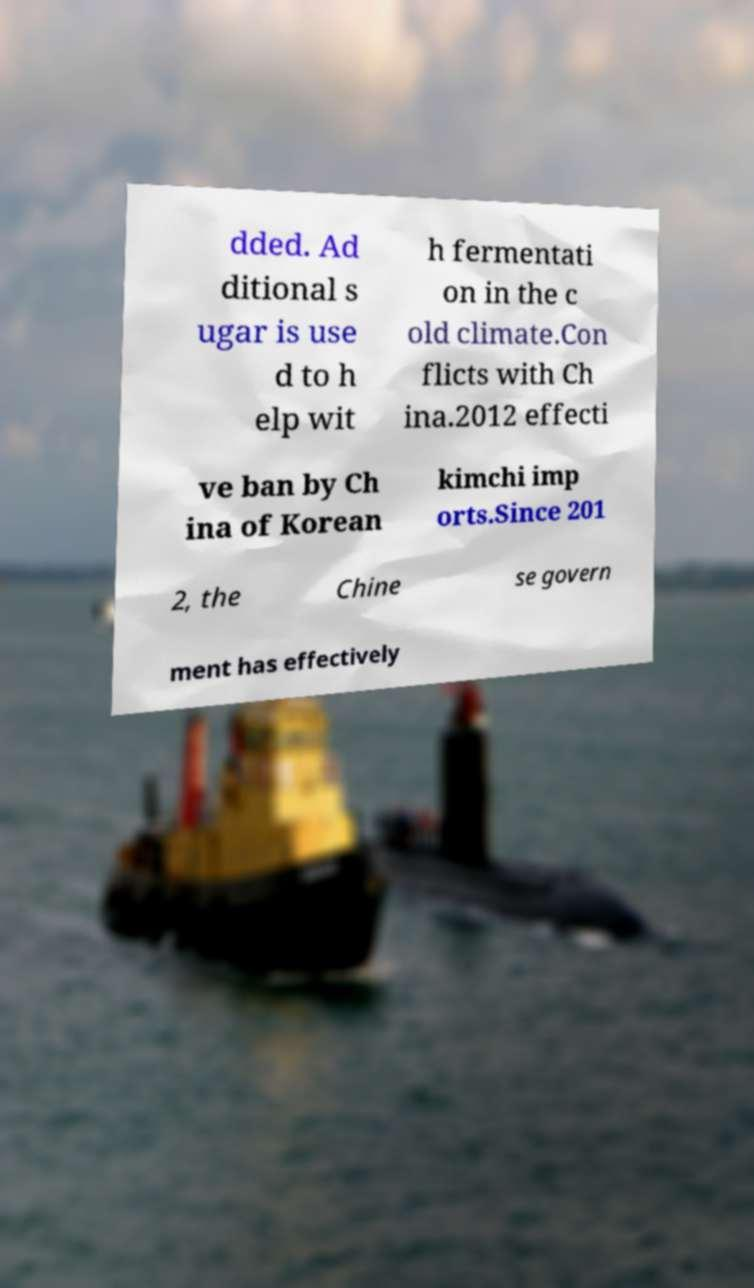For documentation purposes, I need the text within this image transcribed. Could you provide that? dded. Ad ditional s ugar is use d to h elp wit h fermentati on in the c old climate.Con flicts with Ch ina.2012 effecti ve ban by Ch ina of Korean kimchi imp orts.Since 201 2, the Chine se govern ment has effectively 